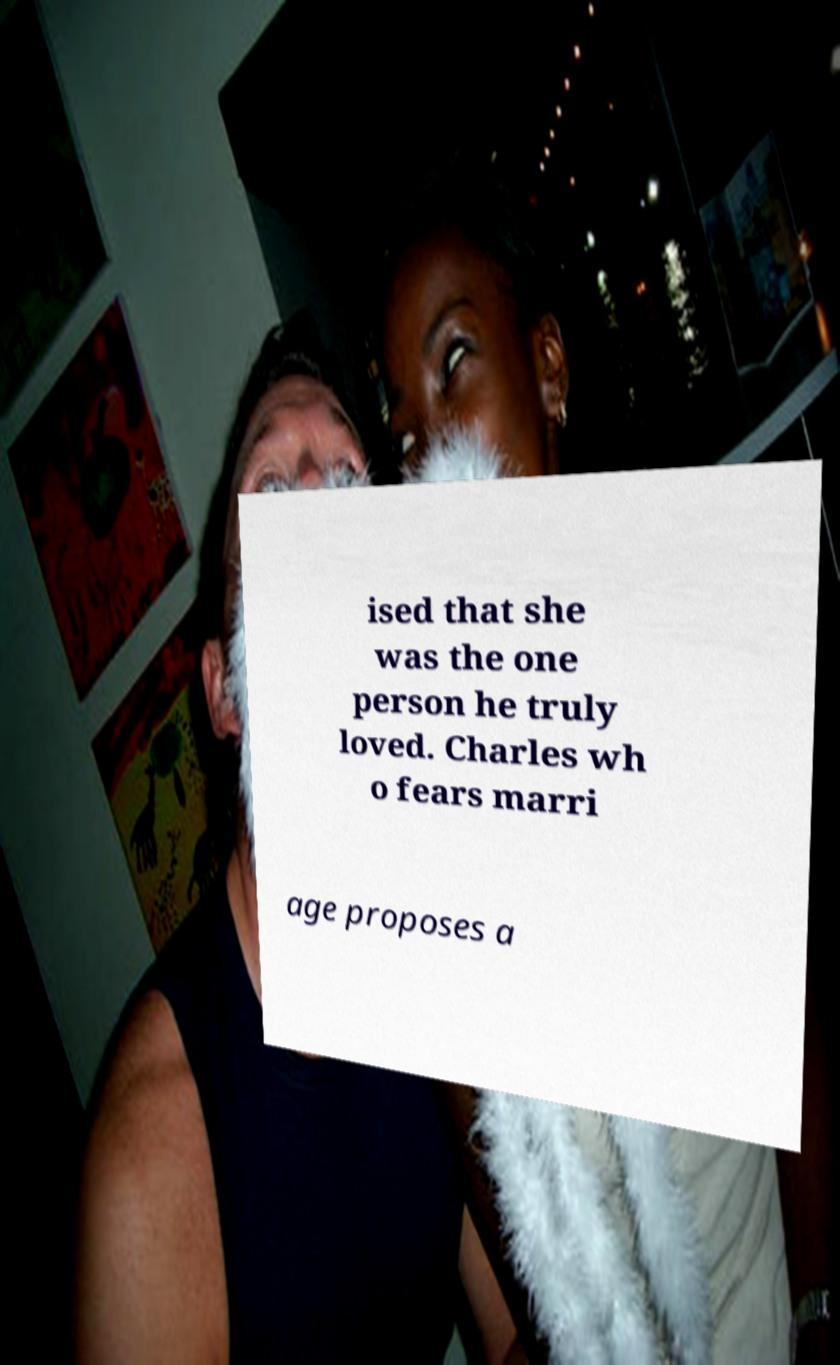I need the written content from this picture converted into text. Can you do that? ised that she was the one person he truly loved. Charles wh o fears marri age proposes a 